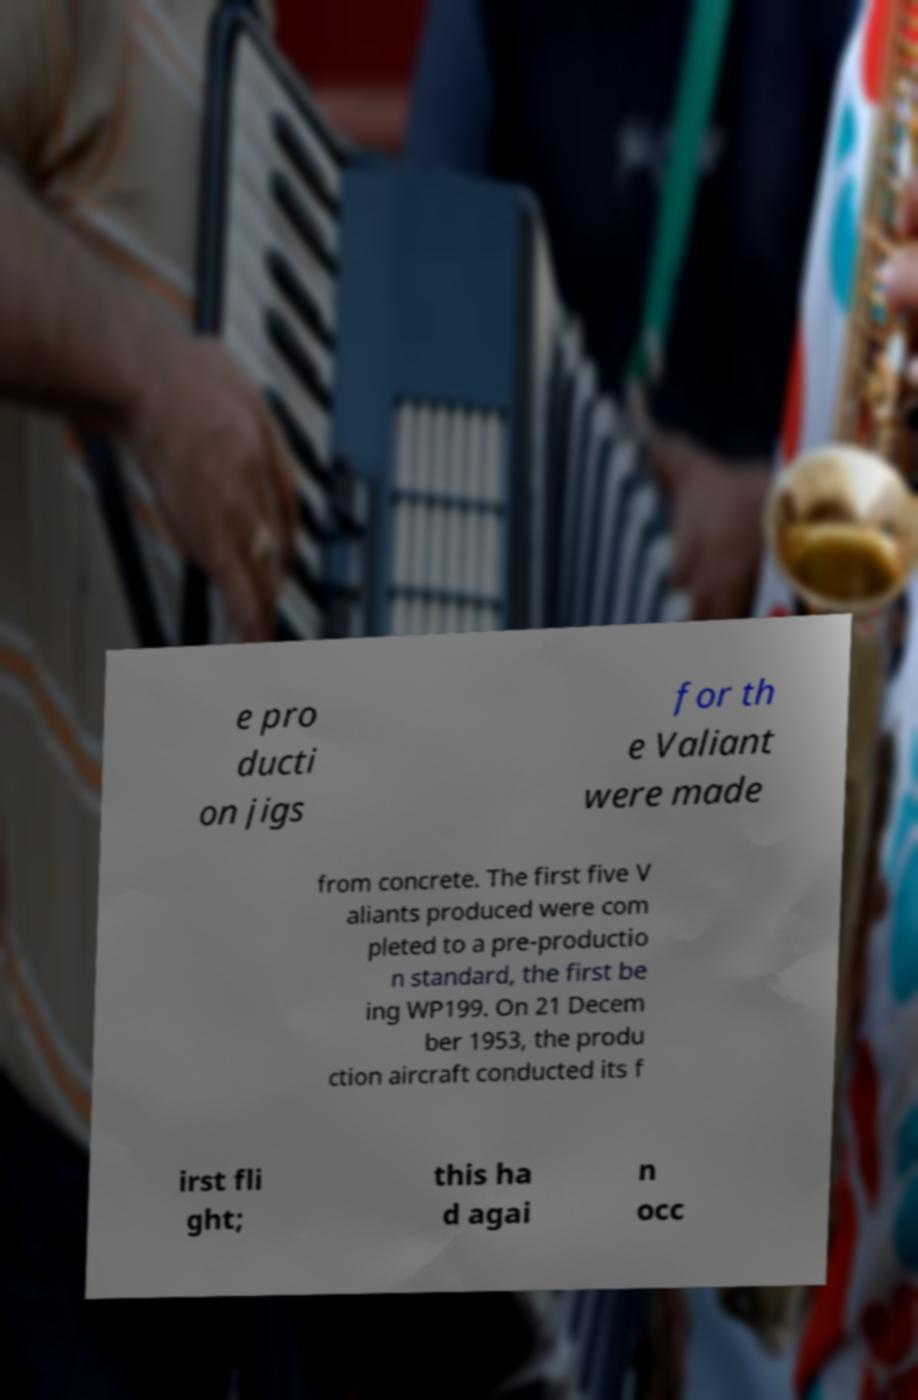Can you read and provide the text displayed in the image?This photo seems to have some interesting text. Can you extract and type it out for me? e pro ducti on jigs for th e Valiant were made from concrete. The first five V aliants produced were com pleted to a pre-productio n standard, the first be ing WP199. On 21 Decem ber 1953, the produ ction aircraft conducted its f irst fli ght; this ha d agai n occ 